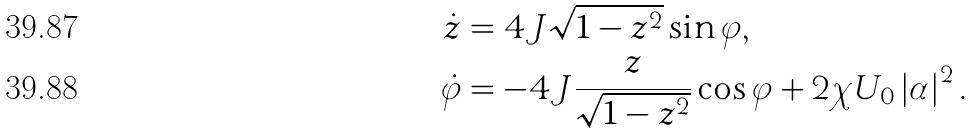Convert formula to latex. <formula><loc_0><loc_0><loc_500><loc_500>\dot { z } & = 4 J \sqrt { 1 - z ^ { 2 } } \sin \varphi , \\ \dot { \varphi } & = - 4 J \frac { z } { \sqrt { 1 - z ^ { 2 } } } \cos \varphi + 2 \chi U _ { 0 } \left | \alpha \right | ^ { 2 } .</formula> 